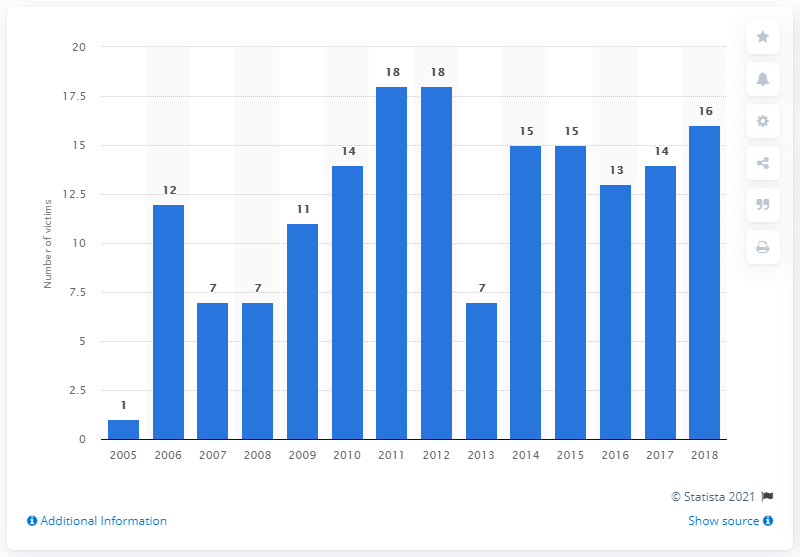Outline some significant characteristics in this image. In 2018, 16 journalists and media support workers were brutally murdered in Mexico, a grim reminder of the dangers that journalists face in pursuit of truth and justice. In 2018, 14 journalists and media support workers were brutally murdered in Mexico. 